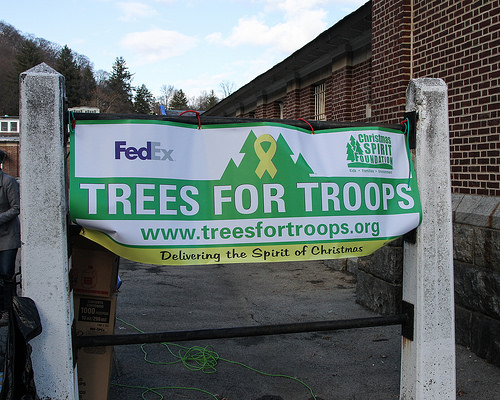<image>
Can you confirm if the sign is in front of the sky? No. The sign is not in front of the sky. The spatial positioning shows a different relationship between these objects. 